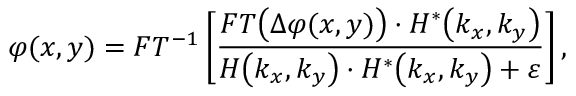Convert formula to latex. <formula><loc_0><loc_0><loc_500><loc_500>\varphi ( x , y ) = F T ^ { - 1 } \left [ \frac { F T \left ( \Delta \varphi ( x , y ) \right ) \cdot H ^ { * } \left ( k _ { x } , k _ { y } \right ) } { H \left ( k _ { x } , k _ { y } \right ) \cdot H ^ { * } \left ( k _ { x } , k _ { y } \right ) + \varepsilon } \right ] ,</formula> 